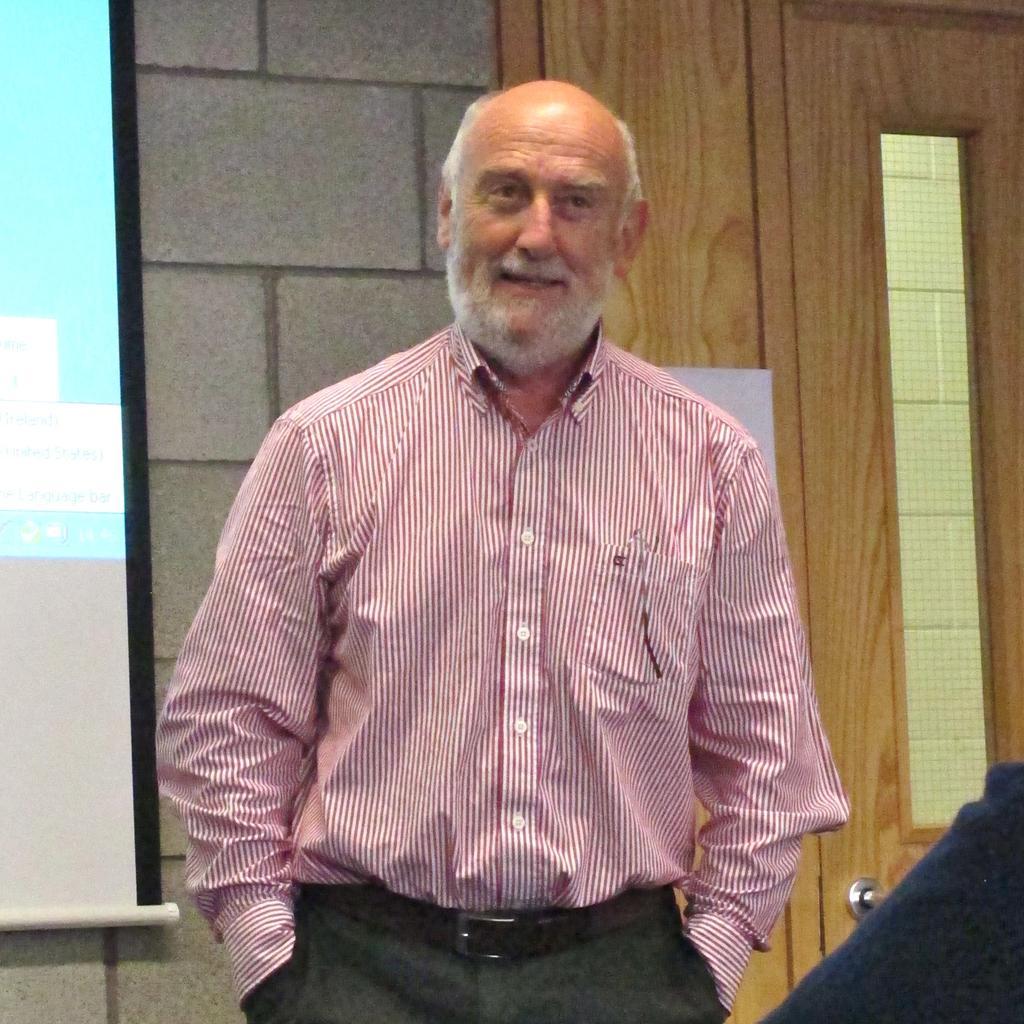Can you describe this image briefly? In this image I can see the person is standing and wearing pink and black color dress. In the background I can see the wall, door and the projection-screen. 